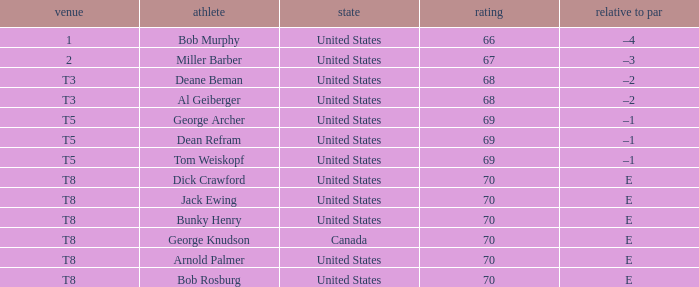What is george archer's home country? United States. 